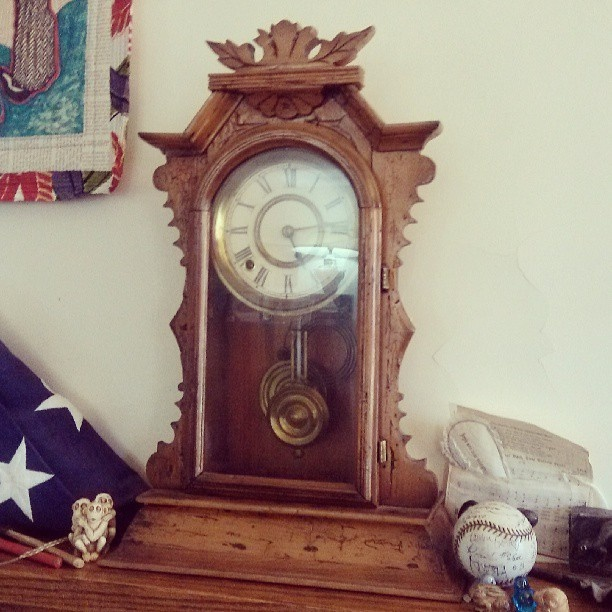Describe the objects in this image and their specific colors. I can see clock in tan, maroon, and brown tones and sports ball in tan, darkgray, lightgray, and gray tones in this image. 